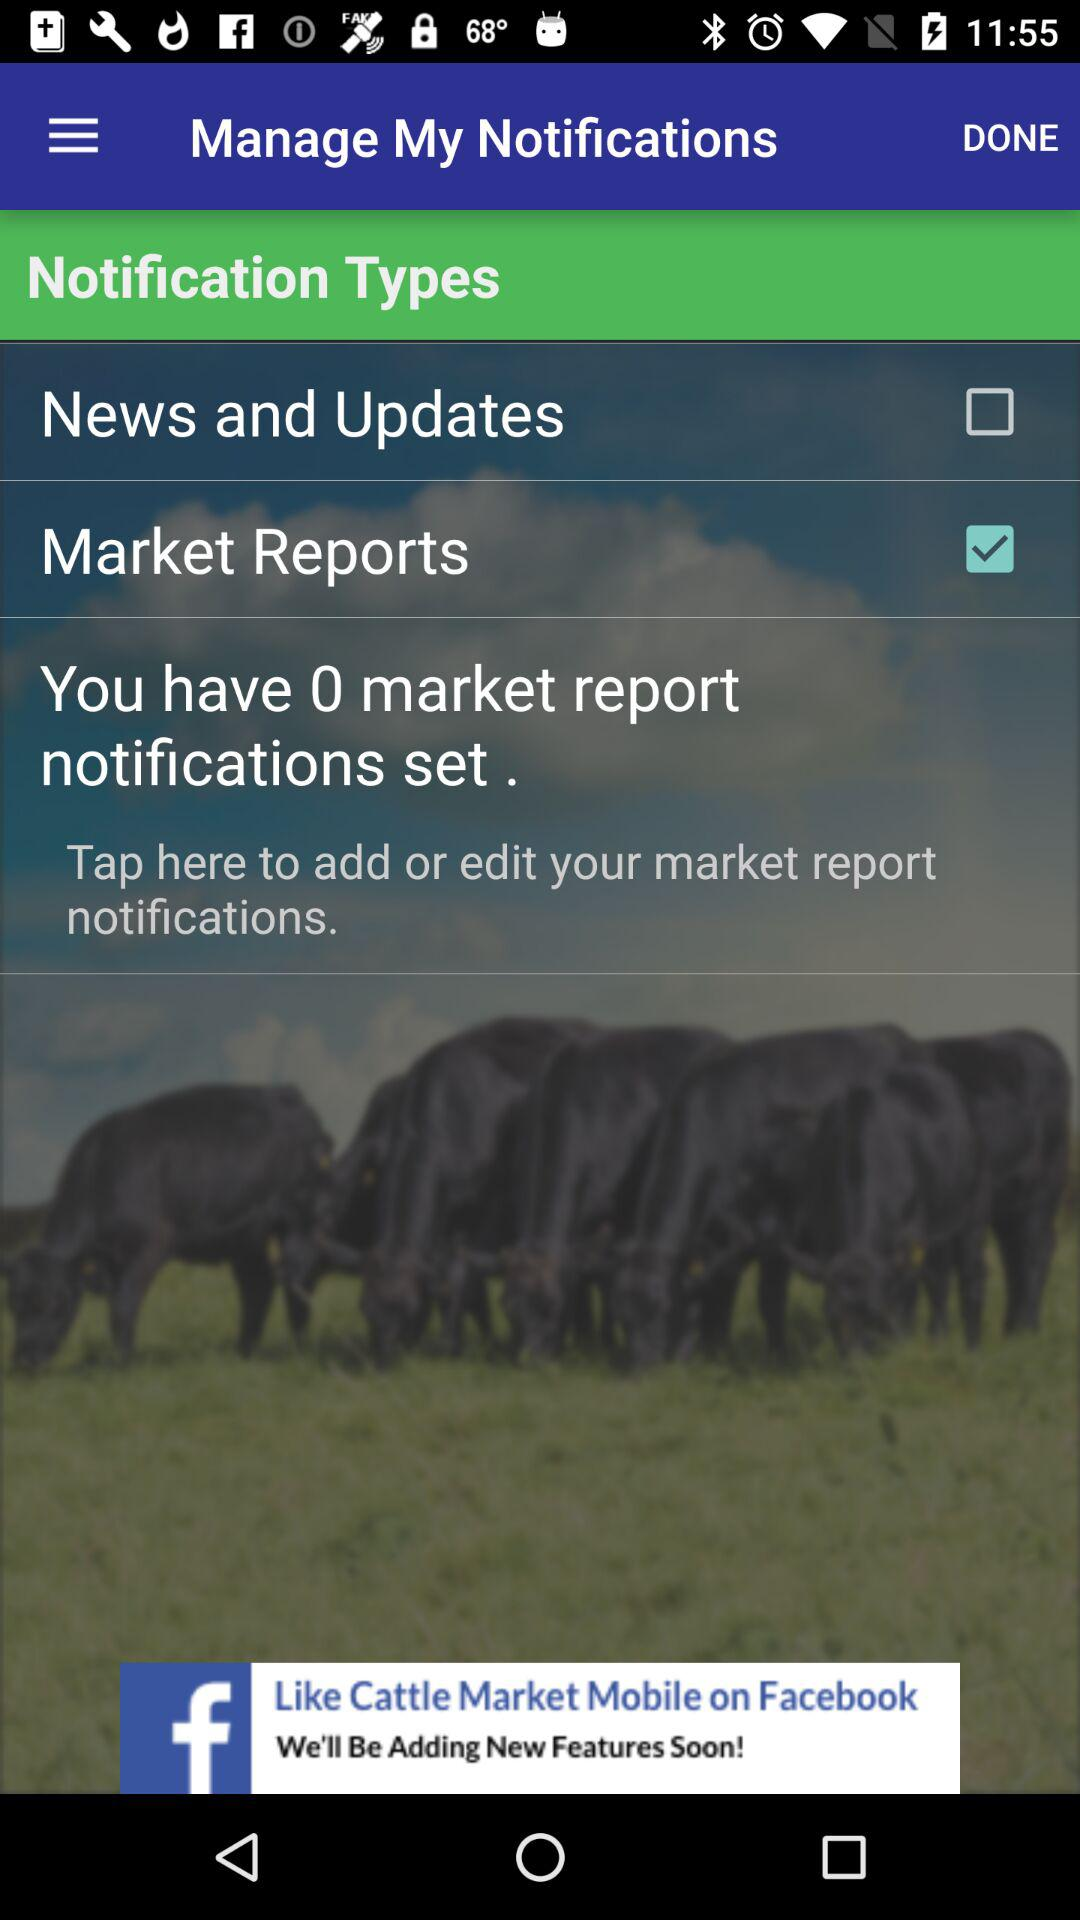Is "Notification Types" checked or unchecked?
When the provided information is insufficient, respond with <no answer>. <no answer> 